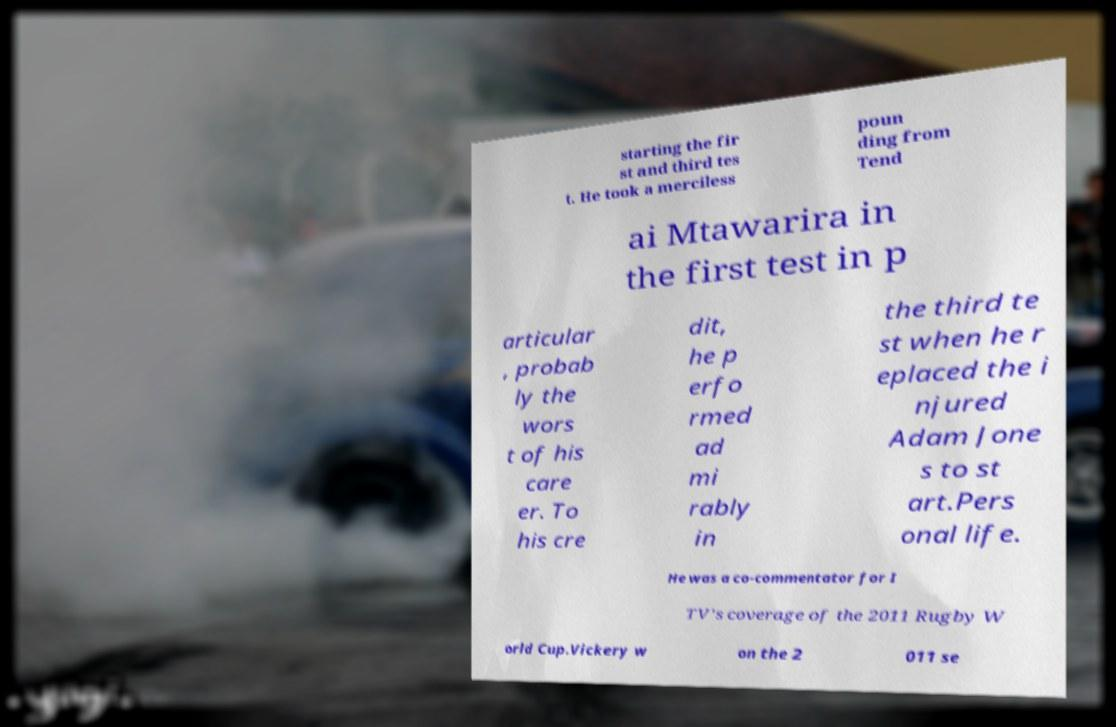Please read and relay the text visible in this image. What does it say? starting the fir st and third tes t. He took a merciless poun ding from Tend ai Mtawarira in the first test in p articular , probab ly the wors t of his care er. To his cre dit, he p erfo rmed ad mi rably in the third te st when he r eplaced the i njured Adam Jone s to st art.Pers onal life. He was a co-commentator for I TV's coverage of the 2011 Rugby W orld Cup.Vickery w on the 2 011 se 